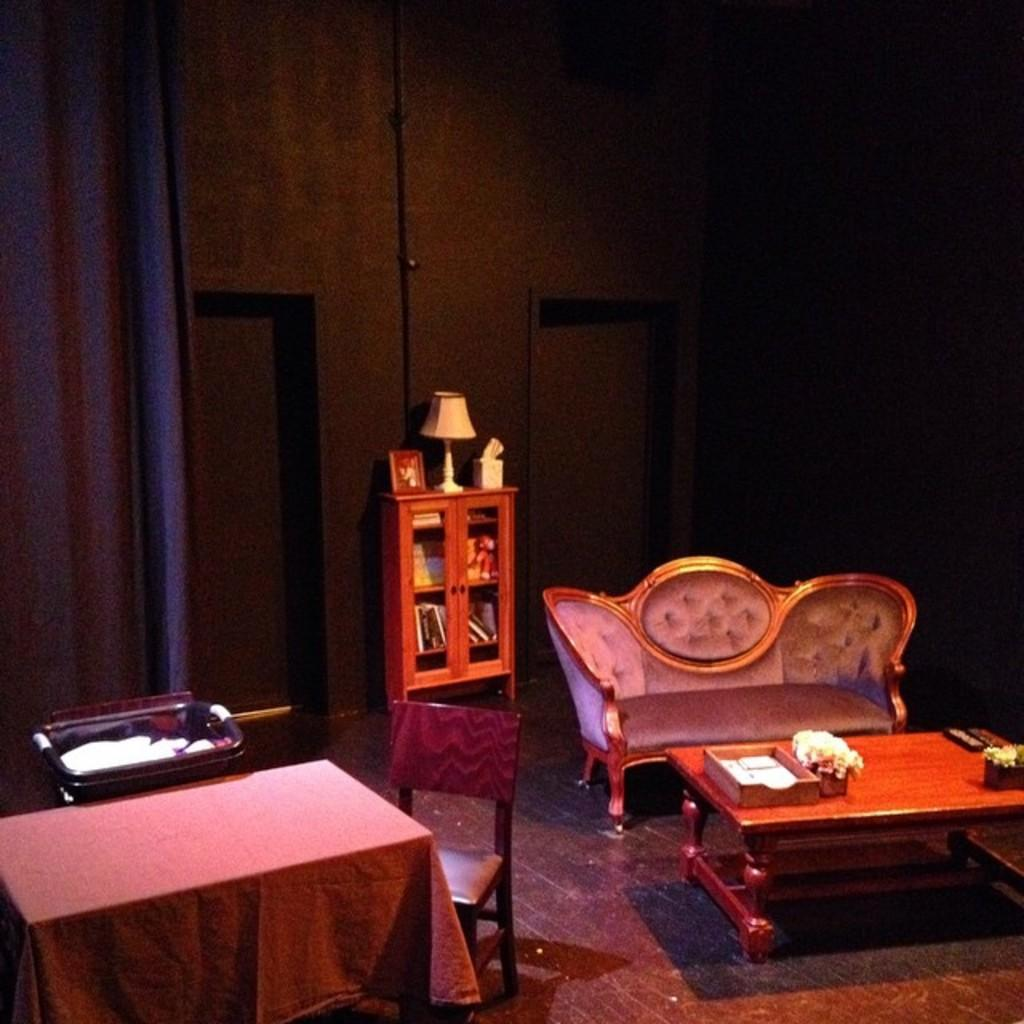What type of furniture is present in the image? There is a sofa, chairs, a table, and a cupboard in the image. What is the purpose of the table in the image? The table is likely used for placing items or as a surface for activities. What type of lighting is present in the image? There is a lamp in the image. What type of window treatment is present in the image? There are curtains in the image. What type of fuel is used to power the lamp in the image? There is no information about the lamp's power source in the image, and therefore we cannot determine the type of fuel used. 